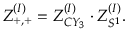Convert formula to latex. <formula><loc_0><loc_0><loc_500><loc_500>Z _ { + , + } ^ { ( I ) } = Z _ { C Y _ { 3 } } ^ { ( I ) } \cdot Z _ { S ^ { 1 } } ^ { ( I ) } .</formula> 